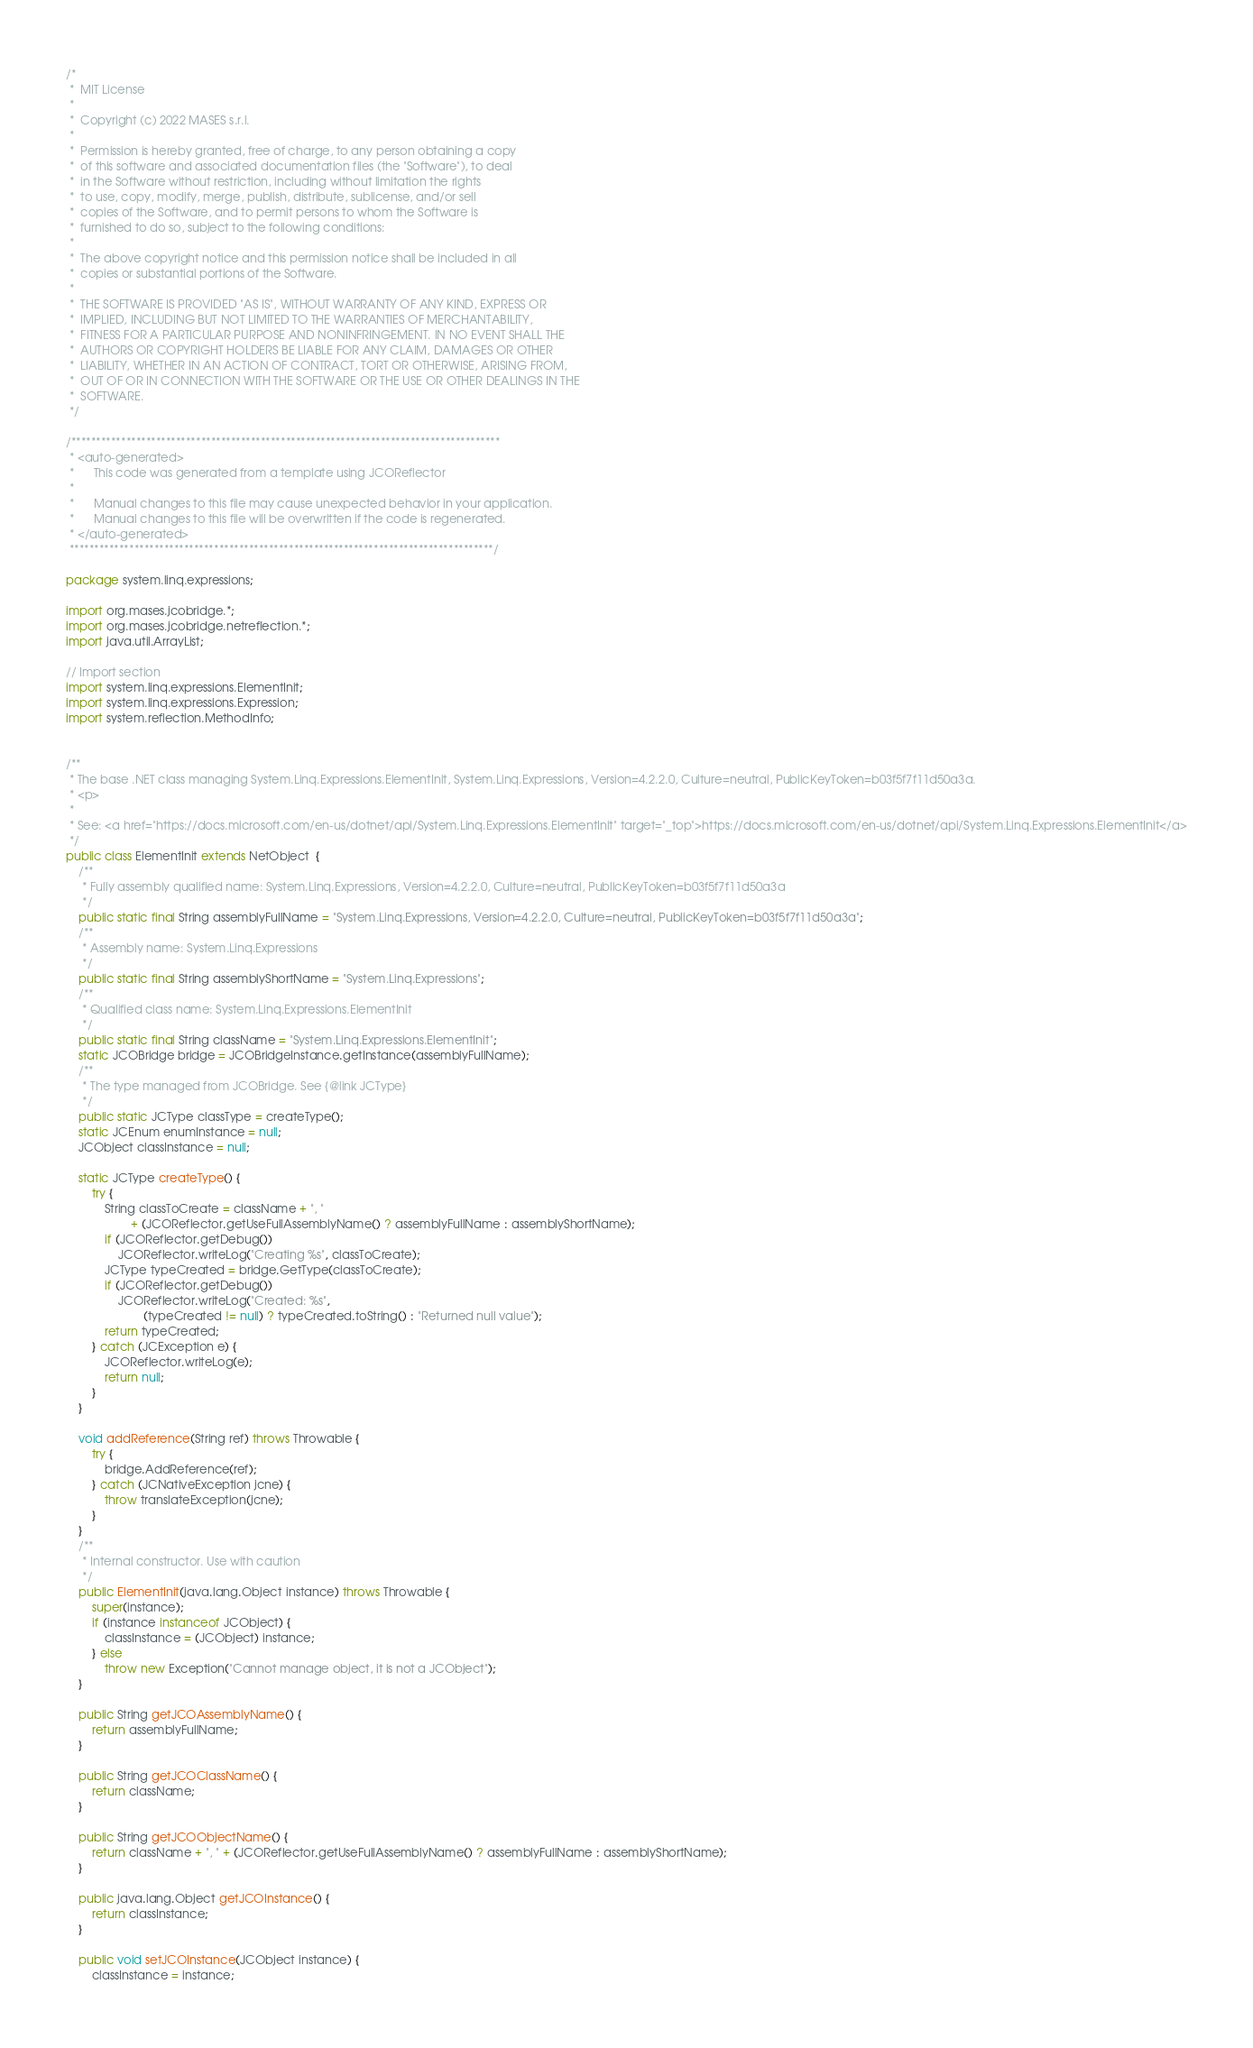Convert code to text. <code><loc_0><loc_0><loc_500><loc_500><_Java_>/*
 *  MIT License
 *
 *  Copyright (c) 2022 MASES s.r.l.
 *
 *  Permission is hereby granted, free of charge, to any person obtaining a copy
 *  of this software and associated documentation files (the "Software"), to deal
 *  in the Software without restriction, including without limitation the rights
 *  to use, copy, modify, merge, publish, distribute, sublicense, and/or sell
 *  copies of the Software, and to permit persons to whom the Software is
 *  furnished to do so, subject to the following conditions:
 *
 *  The above copyright notice and this permission notice shall be included in all
 *  copies or substantial portions of the Software.
 *
 *  THE SOFTWARE IS PROVIDED "AS IS", WITHOUT WARRANTY OF ANY KIND, EXPRESS OR
 *  IMPLIED, INCLUDING BUT NOT LIMITED TO THE WARRANTIES OF MERCHANTABILITY,
 *  FITNESS FOR A PARTICULAR PURPOSE AND NONINFRINGEMENT. IN NO EVENT SHALL THE
 *  AUTHORS OR COPYRIGHT HOLDERS BE LIABLE FOR ANY CLAIM, DAMAGES OR OTHER
 *  LIABILITY, WHETHER IN AN ACTION OF CONTRACT, TORT OR OTHERWISE, ARISING FROM,
 *  OUT OF OR IN CONNECTION WITH THE SOFTWARE OR THE USE OR OTHER DEALINGS IN THE
 *  SOFTWARE.
 */

/**************************************************************************************
 * <auto-generated>
 *      This code was generated from a template using JCOReflector
 * 
 *      Manual changes to this file may cause unexpected behavior in your application.
 *      Manual changes to this file will be overwritten if the code is regenerated.
 * </auto-generated>
 *************************************************************************************/

package system.linq.expressions;

import org.mases.jcobridge.*;
import org.mases.jcobridge.netreflection.*;
import java.util.ArrayList;

// Import section
import system.linq.expressions.ElementInit;
import system.linq.expressions.Expression;
import system.reflection.MethodInfo;


/**
 * The base .NET class managing System.Linq.Expressions.ElementInit, System.Linq.Expressions, Version=4.2.2.0, Culture=neutral, PublicKeyToken=b03f5f7f11d50a3a.
 * <p>
 * 
 * See: <a href="https://docs.microsoft.com/en-us/dotnet/api/System.Linq.Expressions.ElementInit" target="_top">https://docs.microsoft.com/en-us/dotnet/api/System.Linq.Expressions.ElementInit</a>
 */
public class ElementInit extends NetObject  {
    /**
     * Fully assembly qualified name: System.Linq.Expressions, Version=4.2.2.0, Culture=neutral, PublicKeyToken=b03f5f7f11d50a3a
     */
    public static final String assemblyFullName = "System.Linq.Expressions, Version=4.2.2.0, Culture=neutral, PublicKeyToken=b03f5f7f11d50a3a";
    /**
     * Assembly name: System.Linq.Expressions
     */
    public static final String assemblyShortName = "System.Linq.Expressions";
    /**
     * Qualified class name: System.Linq.Expressions.ElementInit
     */
    public static final String className = "System.Linq.Expressions.ElementInit";
    static JCOBridge bridge = JCOBridgeInstance.getInstance(assemblyFullName);
    /**
     * The type managed from JCOBridge. See {@link JCType}
     */
    public static JCType classType = createType();
    static JCEnum enumInstance = null;
    JCObject classInstance = null;

    static JCType createType() {
        try {
            String classToCreate = className + ", "
                    + (JCOReflector.getUseFullAssemblyName() ? assemblyFullName : assemblyShortName);
            if (JCOReflector.getDebug())
                JCOReflector.writeLog("Creating %s", classToCreate);
            JCType typeCreated = bridge.GetType(classToCreate);
            if (JCOReflector.getDebug())
                JCOReflector.writeLog("Created: %s",
                        (typeCreated != null) ? typeCreated.toString() : "Returned null value");
            return typeCreated;
        } catch (JCException e) {
            JCOReflector.writeLog(e);
            return null;
        }
    }

    void addReference(String ref) throws Throwable {
        try {
            bridge.AddReference(ref);
        } catch (JCNativeException jcne) {
            throw translateException(jcne);
        }
    }
    /**
     * Internal constructor. Use with caution 
     */
    public ElementInit(java.lang.Object instance) throws Throwable {
        super(instance);
        if (instance instanceof JCObject) {
            classInstance = (JCObject) instance;
        } else
            throw new Exception("Cannot manage object, it is not a JCObject");
    }

    public String getJCOAssemblyName() {
        return assemblyFullName;
    }

    public String getJCOClassName() {
        return className;
    }

    public String getJCOObjectName() {
        return className + ", " + (JCOReflector.getUseFullAssemblyName() ? assemblyFullName : assemblyShortName);
    }

    public java.lang.Object getJCOInstance() {
        return classInstance;
    }

    public void setJCOInstance(JCObject instance) {
        classInstance = instance;</code> 